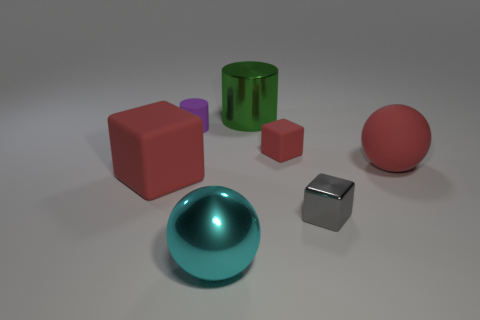Add 3 large red rubber things. How many objects exist? 10 Subtract all spheres. How many objects are left? 5 Subtract 0 brown cylinders. How many objects are left? 7 Subtract all big red matte objects. Subtract all big red matte cubes. How many objects are left? 4 Add 2 small gray metal objects. How many small gray metal objects are left? 3 Add 1 yellow metallic cylinders. How many yellow metallic cylinders exist? 1 